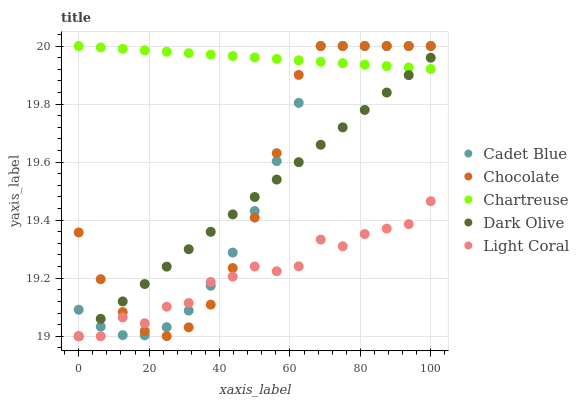Does Light Coral have the minimum area under the curve?
Answer yes or no. Yes. Does Chartreuse have the maximum area under the curve?
Answer yes or no. Yes. Does Chartreuse have the minimum area under the curve?
Answer yes or no. No. Does Light Coral have the maximum area under the curve?
Answer yes or no. No. Is Dark Olive the smoothest?
Answer yes or no. Yes. Is Light Coral the roughest?
Answer yes or no. Yes. Is Chartreuse the smoothest?
Answer yes or no. No. Is Chartreuse the roughest?
Answer yes or no. No. Does Dark Olive have the lowest value?
Answer yes or no. Yes. Does Chartreuse have the lowest value?
Answer yes or no. No. Does Chocolate have the highest value?
Answer yes or no. Yes. Does Light Coral have the highest value?
Answer yes or no. No. Is Light Coral less than Chartreuse?
Answer yes or no. Yes. Is Chartreuse greater than Light Coral?
Answer yes or no. Yes. Does Dark Olive intersect Chocolate?
Answer yes or no. Yes. Is Dark Olive less than Chocolate?
Answer yes or no. No. Is Dark Olive greater than Chocolate?
Answer yes or no. No. Does Light Coral intersect Chartreuse?
Answer yes or no. No. 